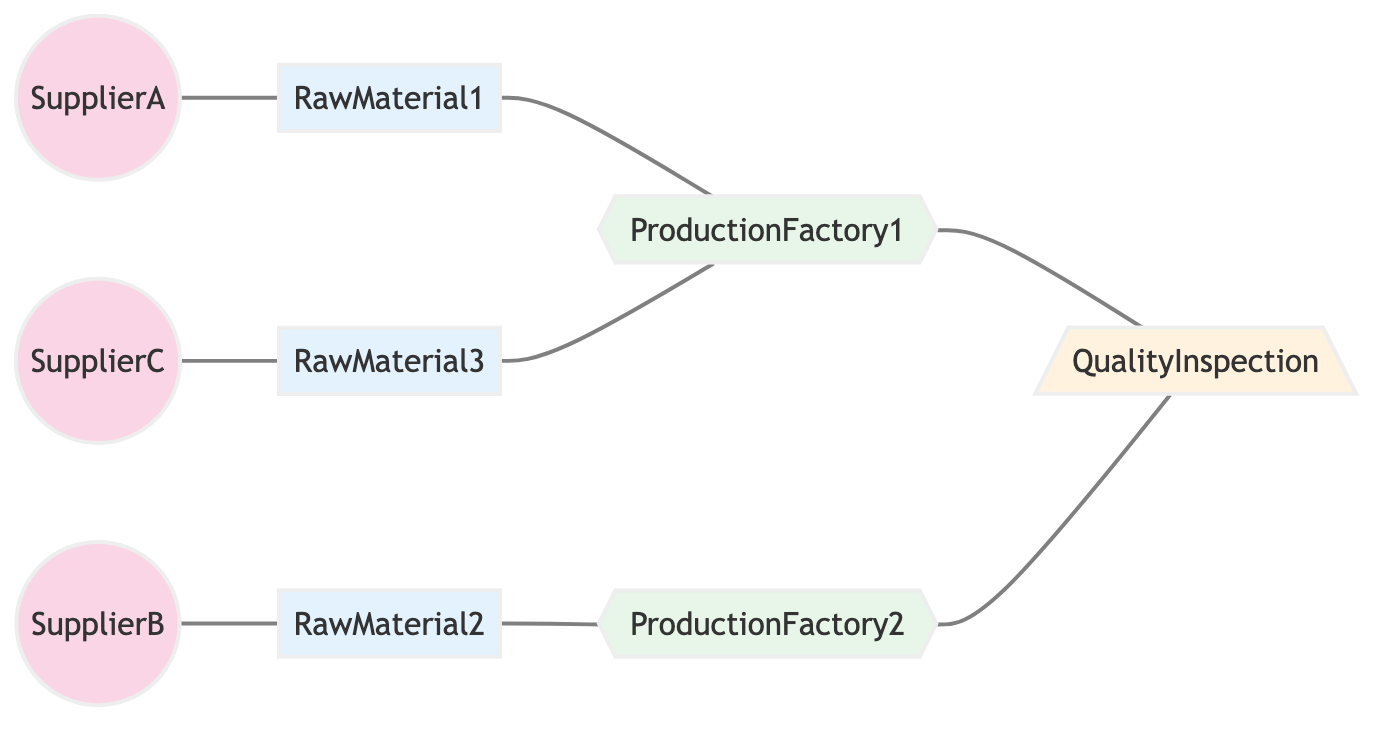What is the total number of nodes in the diagram? The diagram contains nine distinct entities: three suppliers, three raw materials, two factories, and one inspection node. Therefore, adding these together gives a total of nine nodes.
Answer: nine Which supplier supplies Raw Material2? Referring to the edges, we see that SupplierB is connected to Raw Material2 with a "supplies" relationship. Therefore, SupplierB is the supplier of Raw Material2.
Answer: SupplierB How many factories are present in this network? There are two nodes labeled as factories in the diagram: ProductionFactory1 and ProductionFactory2. By counting these nodes, we find that there are two factories.
Answer: two What relationship connects SupplierA to Raw Material1? The edge connecting SupplierA and Raw Material1 is labeled as "supplies." This indicates that SupplierA has a supplying relationship with Raw Material1.
Answer: supplies Which factory processes Raw Material1? The diagram indicates that Raw Material1 is connected to ProductionFactory1 with a "processed in" relationship. Therefore, Raw Material1 is processed in ProductionFactory1.
Answer: ProductionFactory1 How many raw materials are inspected by Quality Inspection? There are two raw materials that connect to Quality Inspection: Raw Material1 and Raw Material2, processed in ProductionFactory1 and ProductionFactory2 respectively, then both are inspected by Quality Inspection. Hence, there are two raw materials inspected by Quality Inspection.
Answer: two Which suppliers are connected to ProductionFactory2? ProductionFactory2 is connected to Raw Material2 via a "processed in" relationship, and Raw Material2 is supplied by SupplierB based on the information from the edges. Thus, SupplierB is connected to ProductionFactory2.
Answer: SupplierB What is the relationship type between ProductionFactory1 and Quality Inspection? The edge between ProductionFactory1 and Quality Inspection is labeled "inspected by," indicating that Quality Inspection inspects the output from ProductionFactory1.
Answer: inspected by Which suppliers supply raw materials that are processed in ProductionFactory1? The suppliers supplying raw materials processed in ProductionFactory1 are SupplierA (for Raw Material1) and SupplierC (for Raw Material3, which is also processed in ProductionFactory1). Therefore, both SupplierA and SupplierC connect to this factory.
Answer: SupplierA, SupplierC 